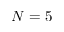Convert formula to latex. <formula><loc_0><loc_0><loc_500><loc_500>N = 5</formula> 